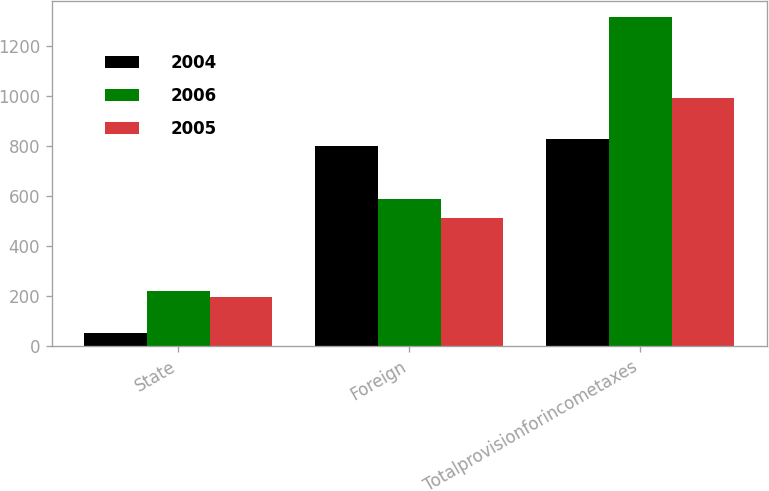Convert chart to OTSL. <chart><loc_0><loc_0><loc_500><loc_500><stacked_bar_chart><ecel><fcel>State<fcel>Foreign<fcel>Totalprovisionforincometaxes<nl><fcel>2004<fcel>55<fcel>800<fcel>828<nl><fcel>2006<fcel>221<fcel>590<fcel>1316<nl><fcel>2005<fcel>197<fcel>515<fcel>994<nl></chart> 